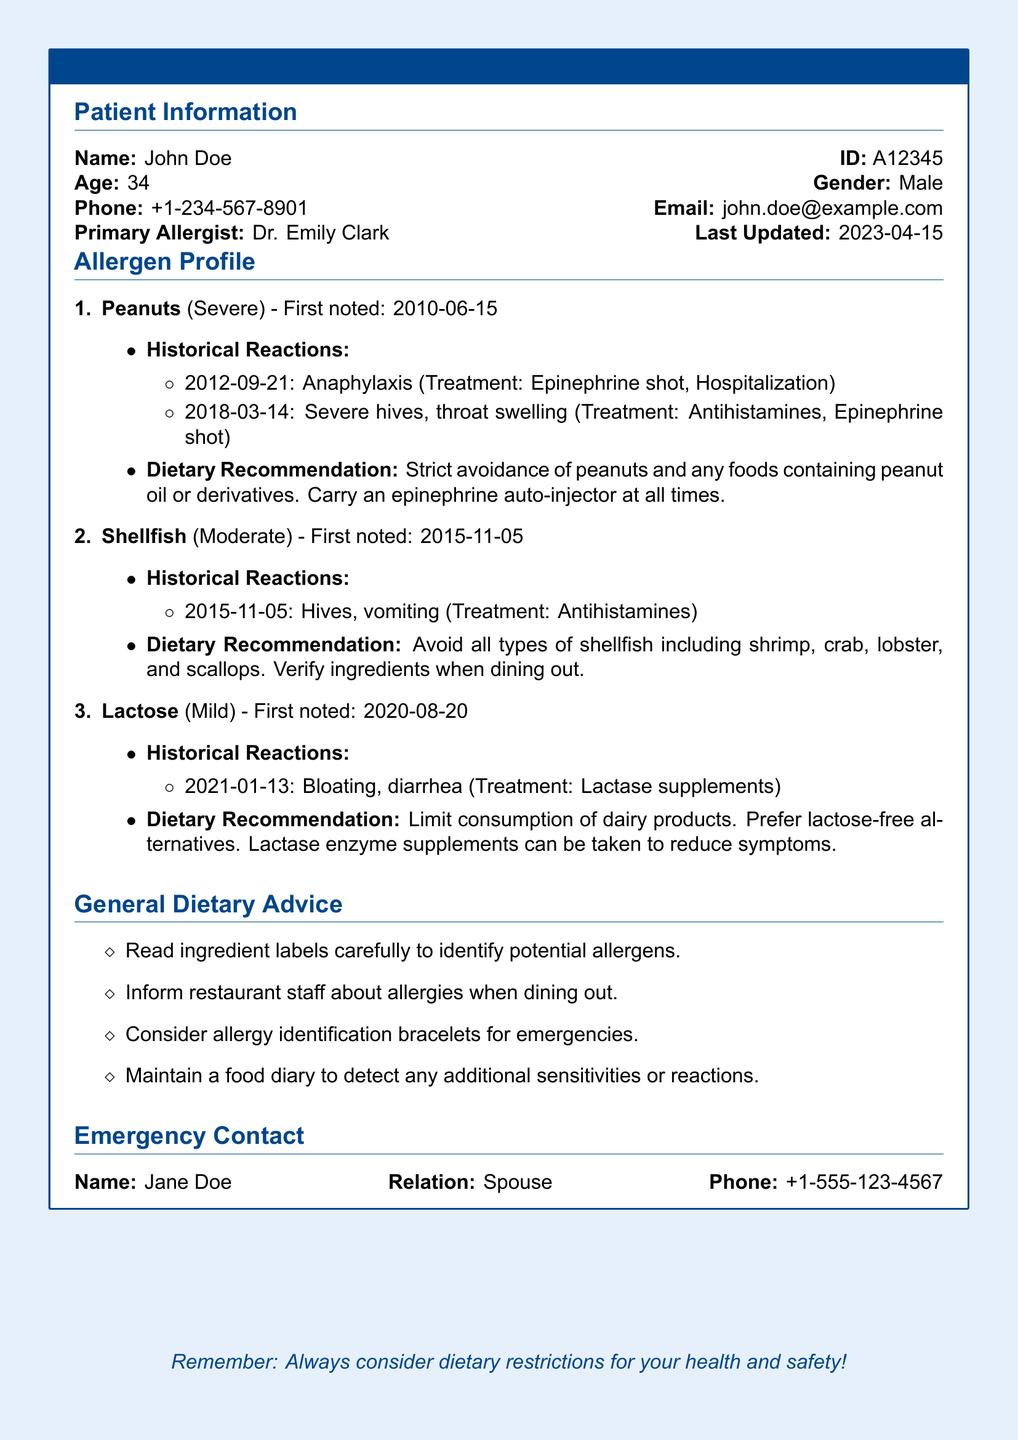What is the patient's name? The name of the patient is specified in the document under Patient Information.
Answer: John Doe What is the primary allergist's name? The primary allergist's name is listed in the Patient Information section of the document.
Answer: Dr. Emily Clark What is the severity classification of the peanut allergy? The severity classification of the peanut allergy is detailed in the Allergen Profile section.
Answer: Severe When did the patient first note the shellfish allergy? The date of the first noting of the shellfish allergy is provided in the Allergen Profile.
Answer: 2015-11-05 What treatment was used for the anaphylaxis reaction in 2012? The treatment for the anaphylaxis reaction is mentioned under Historical Reactions for the peanut allergy.
Answer: Epinephrine shot, Hospitalization What is the dietary recommendation for lactose intolerance? The dietary recommendation for managing lactose intolerance is outlined in the Allergen Profile section.
Answer: Limit consumption of dairy products How many historical reactions are listed for shellfish? The number of historical reactions is noted in the Allergen Profile under the shellfish allergy.
Answer: 1 What is a suggested method to avoid allergic reactions while dining out? A method to prevent allergic reactions while eating out is provided in the General Dietary Advice section.
Answer: Inform restaurant staff about allergies What is the relationship of the emergency contact person to the patient? The relationship of the emergency contact to the patient is included in the Emergency Contact section.
Answer: Spouse 